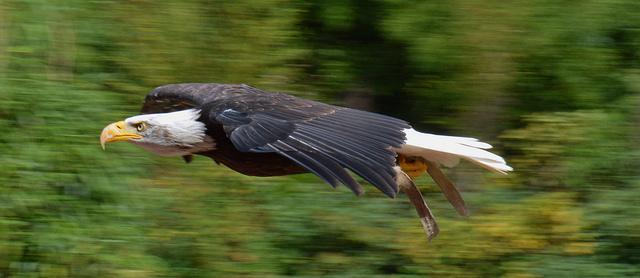What country does this animal represent?
Quick response, please. United states. Where is the cat in this picture?
Concise answer only. Nowhere. Where is this bird flying too?
Write a very short answer. Nest. 